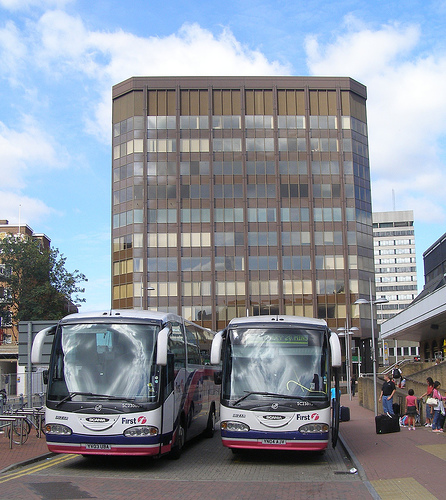What color is the mirror on the left side? There is no visible distinct mirror on the left side; any reflective surfaces are part of the vehicles' design and their colors are primarily of the vehicle itself, which includes white and other colors. 